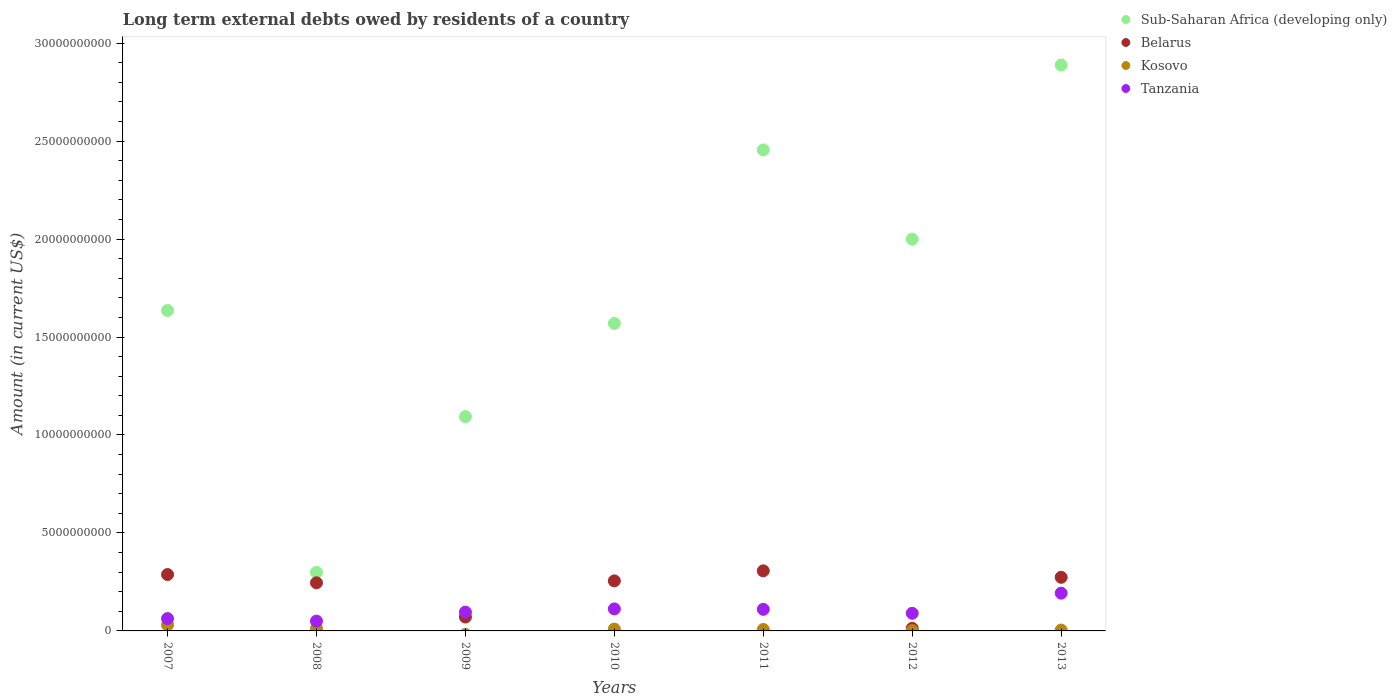Is the number of dotlines equal to the number of legend labels?
Keep it short and to the point. No. What is the amount of long-term external debts owed by residents in Tanzania in 2008?
Make the answer very short. 5.01e+08. Across all years, what is the maximum amount of long-term external debts owed by residents in Kosovo?
Your answer should be very brief. 3.07e+08. Across all years, what is the minimum amount of long-term external debts owed by residents in Tanzania?
Your response must be concise. 5.01e+08. What is the total amount of long-term external debts owed by residents in Belarus in the graph?
Make the answer very short. 1.45e+1. What is the difference between the amount of long-term external debts owed by residents in Sub-Saharan Africa (developing only) in 2010 and that in 2013?
Provide a short and direct response. -1.32e+1. What is the difference between the amount of long-term external debts owed by residents in Belarus in 2009 and the amount of long-term external debts owed by residents in Sub-Saharan Africa (developing only) in 2007?
Provide a short and direct response. -1.56e+1. What is the average amount of long-term external debts owed by residents in Tanzania per year?
Make the answer very short. 1.02e+09. In the year 2013, what is the difference between the amount of long-term external debts owed by residents in Belarus and amount of long-term external debts owed by residents in Kosovo?
Ensure brevity in your answer.  2.69e+09. What is the ratio of the amount of long-term external debts owed by residents in Tanzania in 2008 to that in 2011?
Your answer should be compact. 0.45. What is the difference between the highest and the second highest amount of long-term external debts owed by residents in Sub-Saharan Africa (developing only)?
Your response must be concise. 4.33e+09. What is the difference between the highest and the lowest amount of long-term external debts owed by residents in Sub-Saharan Africa (developing only)?
Offer a terse response. 2.59e+1. In how many years, is the amount of long-term external debts owed by residents in Belarus greater than the average amount of long-term external debts owed by residents in Belarus taken over all years?
Ensure brevity in your answer.  5. Is the sum of the amount of long-term external debts owed by residents in Belarus in 2007 and 2011 greater than the maximum amount of long-term external debts owed by residents in Sub-Saharan Africa (developing only) across all years?
Offer a terse response. No. Is it the case that in every year, the sum of the amount of long-term external debts owed by residents in Tanzania and amount of long-term external debts owed by residents in Sub-Saharan Africa (developing only)  is greater than the sum of amount of long-term external debts owed by residents in Belarus and amount of long-term external debts owed by residents in Kosovo?
Offer a terse response. Yes. Is it the case that in every year, the sum of the amount of long-term external debts owed by residents in Kosovo and amount of long-term external debts owed by residents in Sub-Saharan Africa (developing only)  is greater than the amount of long-term external debts owed by residents in Tanzania?
Ensure brevity in your answer.  Yes. Does the amount of long-term external debts owed by residents in Sub-Saharan Africa (developing only) monotonically increase over the years?
Keep it short and to the point. No. Is the amount of long-term external debts owed by residents in Sub-Saharan Africa (developing only) strictly greater than the amount of long-term external debts owed by residents in Belarus over the years?
Your answer should be compact. Yes. How many years are there in the graph?
Give a very brief answer. 7. Are the values on the major ticks of Y-axis written in scientific E-notation?
Your response must be concise. No. Does the graph contain grids?
Make the answer very short. No. How many legend labels are there?
Your response must be concise. 4. What is the title of the graph?
Make the answer very short. Long term external debts owed by residents of a country. Does "Slovenia" appear as one of the legend labels in the graph?
Offer a very short reply. No. What is the label or title of the X-axis?
Offer a terse response. Years. What is the Amount (in current US$) in Sub-Saharan Africa (developing only) in 2007?
Offer a terse response. 1.64e+1. What is the Amount (in current US$) in Belarus in 2007?
Your response must be concise. 2.88e+09. What is the Amount (in current US$) in Kosovo in 2007?
Provide a succinct answer. 3.07e+08. What is the Amount (in current US$) of Tanzania in 2007?
Provide a short and direct response. 6.30e+08. What is the Amount (in current US$) of Sub-Saharan Africa (developing only) in 2008?
Make the answer very short. 2.99e+09. What is the Amount (in current US$) in Belarus in 2008?
Provide a succinct answer. 2.46e+09. What is the Amount (in current US$) in Kosovo in 2008?
Offer a very short reply. 1.24e+08. What is the Amount (in current US$) in Tanzania in 2008?
Ensure brevity in your answer.  5.01e+08. What is the Amount (in current US$) of Sub-Saharan Africa (developing only) in 2009?
Offer a terse response. 1.09e+1. What is the Amount (in current US$) of Belarus in 2009?
Give a very brief answer. 7.09e+08. What is the Amount (in current US$) of Tanzania in 2009?
Provide a short and direct response. 9.60e+08. What is the Amount (in current US$) in Sub-Saharan Africa (developing only) in 2010?
Your answer should be compact. 1.57e+1. What is the Amount (in current US$) in Belarus in 2010?
Your answer should be compact. 2.55e+09. What is the Amount (in current US$) of Kosovo in 2010?
Your response must be concise. 9.39e+07. What is the Amount (in current US$) in Tanzania in 2010?
Your answer should be very brief. 1.12e+09. What is the Amount (in current US$) of Sub-Saharan Africa (developing only) in 2011?
Provide a succinct answer. 2.45e+1. What is the Amount (in current US$) in Belarus in 2011?
Ensure brevity in your answer.  3.07e+09. What is the Amount (in current US$) in Kosovo in 2011?
Your answer should be very brief. 7.35e+07. What is the Amount (in current US$) of Tanzania in 2011?
Offer a very short reply. 1.10e+09. What is the Amount (in current US$) of Sub-Saharan Africa (developing only) in 2012?
Offer a terse response. 2.00e+1. What is the Amount (in current US$) in Belarus in 2012?
Your answer should be compact. 1.30e+08. What is the Amount (in current US$) of Kosovo in 2012?
Provide a succinct answer. 1.53e+07. What is the Amount (in current US$) in Tanzania in 2012?
Give a very brief answer. 9.00e+08. What is the Amount (in current US$) in Sub-Saharan Africa (developing only) in 2013?
Provide a short and direct response. 2.89e+1. What is the Amount (in current US$) in Belarus in 2013?
Ensure brevity in your answer.  2.74e+09. What is the Amount (in current US$) in Kosovo in 2013?
Offer a very short reply. 4.40e+07. What is the Amount (in current US$) of Tanzania in 2013?
Provide a short and direct response. 1.93e+09. Across all years, what is the maximum Amount (in current US$) in Sub-Saharan Africa (developing only)?
Keep it short and to the point. 2.89e+1. Across all years, what is the maximum Amount (in current US$) in Belarus?
Keep it short and to the point. 3.07e+09. Across all years, what is the maximum Amount (in current US$) of Kosovo?
Offer a very short reply. 3.07e+08. Across all years, what is the maximum Amount (in current US$) of Tanzania?
Ensure brevity in your answer.  1.93e+09. Across all years, what is the minimum Amount (in current US$) of Sub-Saharan Africa (developing only)?
Give a very brief answer. 2.99e+09. Across all years, what is the minimum Amount (in current US$) in Belarus?
Offer a terse response. 1.30e+08. Across all years, what is the minimum Amount (in current US$) of Tanzania?
Give a very brief answer. 5.01e+08. What is the total Amount (in current US$) of Sub-Saharan Africa (developing only) in the graph?
Offer a terse response. 1.19e+11. What is the total Amount (in current US$) of Belarus in the graph?
Your answer should be compact. 1.45e+1. What is the total Amount (in current US$) in Kosovo in the graph?
Your answer should be compact. 6.57e+08. What is the total Amount (in current US$) of Tanzania in the graph?
Offer a very short reply. 7.14e+09. What is the difference between the Amount (in current US$) of Sub-Saharan Africa (developing only) in 2007 and that in 2008?
Provide a succinct answer. 1.34e+1. What is the difference between the Amount (in current US$) in Belarus in 2007 and that in 2008?
Provide a succinct answer. 4.21e+08. What is the difference between the Amount (in current US$) of Kosovo in 2007 and that in 2008?
Your answer should be very brief. 1.83e+08. What is the difference between the Amount (in current US$) in Tanzania in 2007 and that in 2008?
Give a very brief answer. 1.29e+08. What is the difference between the Amount (in current US$) in Sub-Saharan Africa (developing only) in 2007 and that in 2009?
Offer a terse response. 5.42e+09. What is the difference between the Amount (in current US$) of Belarus in 2007 and that in 2009?
Provide a short and direct response. 2.17e+09. What is the difference between the Amount (in current US$) in Tanzania in 2007 and that in 2009?
Offer a terse response. -3.30e+08. What is the difference between the Amount (in current US$) of Sub-Saharan Africa (developing only) in 2007 and that in 2010?
Keep it short and to the point. 6.61e+08. What is the difference between the Amount (in current US$) of Belarus in 2007 and that in 2010?
Your answer should be compact. 3.24e+08. What is the difference between the Amount (in current US$) in Kosovo in 2007 and that in 2010?
Ensure brevity in your answer.  2.13e+08. What is the difference between the Amount (in current US$) of Tanzania in 2007 and that in 2010?
Provide a short and direct response. -4.93e+08. What is the difference between the Amount (in current US$) in Sub-Saharan Africa (developing only) in 2007 and that in 2011?
Give a very brief answer. -8.20e+09. What is the difference between the Amount (in current US$) in Belarus in 2007 and that in 2011?
Ensure brevity in your answer.  -1.90e+08. What is the difference between the Amount (in current US$) in Kosovo in 2007 and that in 2011?
Your answer should be very brief. 2.33e+08. What is the difference between the Amount (in current US$) of Tanzania in 2007 and that in 2011?
Keep it short and to the point. -4.73e+08. What is the difference between the Amount (in current US$) of Sub-Saharan Africa (developing only) in 2007 and that in 2012?
Keep it short and to the point. -3.64e+09. What is the difference between the Amount (in current US$) in Belarus in 2007 and that in 2012?
Your answer should be compact. 2.75e+09. What is the difference between the Amount (in current US$) in Kosovo in 2007 and that in 2012?
Keep it short and to the point. 2.91e+08. What is the difference between the Amount (in current US$) of Tanzania in 2007 and that in 2012?
Your answer should be very brief. -2.70e+08. What is the difference between the Amount (in current US$) in Sub-Saharan Africa (developing only) in 2007 and that in 2013?
Keep it short and to the point. -1.25e+1. What is the difference between the Amount (in current US$) of Belarus in 2007 and that in 2013?
Offer a very short reply. 1.40e+08. What is the difference between the Amount (in current US$) in Kosovo in 2007 and that in 2013?
Keep it short and to the point. 2.63e+08. What is the difference between the Amount (in current US$) of Tanzania in 2007 and that in 2013?
Keep it short and to the point. -1.30e+09. What is the difference between the Amount (in current US$) in Sub-Saharan Africa (developing only) in 2008 and that in 2009?
Provide a succinct answer. -7.95e+09. What is the difference between the Amount (in current US$) of Belarus in 2008 and that in 2009?
Provide a succinct answer. 1.75e+09. What is the difference between the Amount (in current US$) in Tanzania in 2008 and that in 2009?
Offer a very short reply. -4.59e+08. What is the difference between the Amount (in current US$) of Sub-Saharan Africa (developing only) in 2008 and that in 2010?
Provide a succinct answer. -1.27e+1. What is the difference between the Amount (in current US$) in Belarus in 2008 and that in 2010?
Your answer should be very brief. -9.73e+07. What is the difference between the Amount (in current US$) in Kosovo in 2008 and that in 2010?
Ensure brevity in your answer.  2.99e+07. What is the difference between the Amount (in current US$) of Tanzania in 2008 and that in 2010?
Provide a short and direct response. -6.22e+08. What is the difference between the Amount (in current US$) of Sub-Saharan Africa (developing only) in 2008 and that in 2011?
Give a very brief answer. -2.16e+1. What is the difference between the Amount (in current US$) of Belarus in 2008 and that in 2011?
Your response must be concise. -6.11e+08. What is the difference between the Amount (in current US$) in Kosovo in 2008 and that in 2011?
Your answer should be compact. 5.03e+07. What is the difference between the Amount (in current US$) of Tanzania in 2008 and that in 2011?
Your answer should be compact. -6.02e+08. What is the difference between the Amount (in current US$) of Sub-Saharan Africa (developing only) in 2008 and that in 2012?
Keep it short and to the point. -1.70e+1. What is the difference between the Amount (in current US$) in Belarus in 2008 and that in 2012?
Offer a very short reply. 2.33e+09. What is the difference between the Amount (in current US$) of Kosovo in 2008 and that in 2012?
Your answer should be very brief. 1.08e+08. What is the difference between the Amount (in current US$) of Tanzania in 2008 and that in 2012?
Provide a short and direct response. -3.99e+08. What is the difference between the Amount (in current US$) in Sub-Saharan Africa (developing only) in 2008 and that in 2013?
Make the answer very short. -2.59e+1. What is the difference between the Amount (in current US$) of Belarus in 2008 and that in 2013?
Ensure brevity in your answer.  -2.81e+08. What is the difference between the Amount (in current US$) of Kosovo in 2008 and that in 2013?
Your answer should be compact. 7.98e+07. What is the difference between the Amount (in current US$) of Tanzania in 2008 and that in 2013?
Your response must be concise. -1.43e+09. What is the difference between the Amount (in current US$) in Sub-Saharan Africa (developing only) in 2009 and that in 2010?
Offer a very short reply. -4.76e+09. What is the difference between the Amount (in current US$) in Belarus in 2009 and that in 2010?
Offer a very short reply. -1.84e+09. What is the difference between the Amount (in current US$) of Tanzania in 2009 and that in 2010?
Keep it short and to the point. -1.63e+08. What is the difference between the Amount (in current US$) of Sub-Saharan Africa (developing only) in 2009 and that in 2011?
Your response must be concise. -1.36e+1. What is the difference between the Amount (in current US$) in Belarus in 2009 and that in 2011?
Give a very brief answer. -2.36e+09. What is the difference between the Amount (in current US$) of Tanzania in 2009 and that in 2011?
Provide a succinct answer. -1.43e+08. What is the difference between the Amount (in current US$) of Sub-Saharan Africa (developing only) in 2009 and that in 2012?
Keep it short and to the point. -9.06e+09. What is the difference between the Amount (in current US$) in Belarus in 2009 and that in 2012?
Offer a terse response. 5.79e+08. What is the difference between the Amount (in current US$) in Tanzania in 2009 and that in 2012?
Make the answer very short. 6.00e+07. What is the difference between the Amount (in current US$) in Sub-Saharan Africa (developing only) in 2009 and that in 2013?
Give a very brief answer. -1.79e+1. What is the difference between the Amount (in current US$) of Belarus in 2009 and that in 2013?
Provide a short and direct response. -2.03e+09. What is the difference between the Amount (in current US$) of Tanzania in 2009 and that in 2013?
Provide a succinct answer. -9.67e+08. What is the difference between the Amount (in current US$) of Sub-Saharan Africa (developing only) in 2010 and that in 2011?
Your answer should be very brief. -8.86e+09. What is the difference between the Amount (in current US$) of Belarus in 2010 and that in 2011?
Make the answer very short. -5.14e+08. What is the difference between the Amount (in current US$) of Kosovo in 2010 and that in 2011?
Make the answer very short. 2.04e+07. What is the difference between the Amount (in current US$) of Tanzania in 2010 and that in 2011?
Provide a short and direct response. 2.01e+07. What is the difference between the Amount (in current US$) of Sub-Saharan Africa (developing only) in 2010 and that in 2012?
Provide a short and direct response. -4.30e+09. What is the difference between the Amount (in current US$) of Belarus in 2010 and that in 2012?
Make the answer very short. 2.42e+09. What is the difference between the Amount (in current US$) in Kosovo in 2010 and that in 2012?
Offer a terse response. 7.86e+07. What is the difference between the Amount (in current US$) in Tanzania in 2010 and that in 2012?
Make the answer very short. 2.23e+08. What is the difference between the Amount (in current US$) in Sub-Saharan Africa (developing only) in 2010 and that in 2013?
Provide a short and direct response. -1.32e+1. What is the difference between the Amount (in current US$) of Belarus in 2010 and that in 2013?
Provide a short and direct response. -1.83e+08. What is the difference between the Amount (in current US$) in Kosovo in 2010 and that in 2013?
Keep it short and to the point. 5.00e+07. What is the difference between the Amount (in current US$) in Tanzania in 2010 and that in 2013?
Ensure brevity in your answer.  -8.04e+08. What is the difference between the Amount (in current US$) of Sub-Saharan Africa (developing only) in 2011 and that in 2012?
Make the answer very short. 4.55e+09. What is the difference between the Amount (in current US$) in Belarus in 2011 and that in 2012?
Provide a succinct answer. 2.94e+09. What is the difference between the Amount (in current US$) of Kosovo in 2011 and that in 2012?
Offer a very short reply. 5.82e+07. What is the difference between the Amount (in current US$) in Tanzania in 2011 and that in 2012?
Provide a succinct answer. 2.03e+08. What is the difference between the Amount (in current US$) in Sub-Saharan Africa (developing only) in 2011 and that in 2013?
Offer a terse response. -4.33e+09. What is the difference between the Amount (in current US$) in Belarus in 2011 and that in 2013?
Give a very brief answer. 3.30e+08. What is the difference between the Amount (in current US$) in Kosovo in 2011 and that in 2013?
Ensure brevity in your answer.  2.95e+07. What is the difference between the Amount (in current US$) of Tanzania in 2011 and that in 2013?
Offer a terse response. -8.24e+08. What is the difference between the Amount (in current US$) of Sub-Saharan Africa (developing only) in 2012 and that in 2013?
Keep it short and to the point. -8.89e+09. What is the difference between the Amount (in current US$) in Belarus in 2012 and that in 2013?
Make the answer very short. -2.61e+09. What is the difference between the Amount (in current US$) in Kosovo in 2012 and that in 2013?
Your answer should be compact. -2.87e+07. What is the difference between the Amount (in current US$) in Tanzania in 2012 and that in 2013?
Your response must be concise. -1.03e+09. What is the difference between the Amount (in current US$) in Sub-Saharan Africa (developing only) in 2007 and the Amount (in current US$) in Belarus in 2008?
Provide a succinct answer. 1.39e+1. What is the difference between the Amount (in current US$) in Sub-Saharan Africa (developing only) in 2007 and the Amount (in current US$) in Kosovo in 2008?
Your answer should be very brief. 1.62e+1. What is the difference between the Amount (in current US$) in Sub-Saharan Africa (developing only) in 2007 and the Amount (in current US$) in Tanzania in 2008?
Offer a very short reply. 1.59e+1. What is the difference between the Amount (in current US$) of Belarus in 2007 and the Amount (in current US$) of Kosovo in 2008?
Offer a terse response. 2.75e+09. What is the difference between the Amount (in current US$) of Belarus in 2007 and the Amount (in current US$) of Tanzania in 2008?
Provide a succinct answer. 2.38e+09. What is the difference between the Amount (in current US$) in Kosovo in 2007 and the Amount (in current US$) in Tanzania in 2008?
Give a very brief answer. -1.94e+08. What is the difference between the Amount (in current US$) of Sub-Saharan Africa (developing only) in 2007 and the Amount (in current US$) of Belarus in 2009?
Your response must be concise. 1.56e+1. What is the difference between the Amount (in current US$) in Sub-Saharan Africa (developing only) in 2007 and the Amount (in current US$) in Tanzania in 2009?
Your answer should be very brief. 1.54e+1. What is the difference between the Amount (in current US$) of Belarus in 2007 and the Amount (in current US$) of Tanzania in 2009?
Provide a short and direct response. 1.92e+09. What is the difference between the Amount (in current US$) in Kosovo in 2007 and the Amount (in current US$) in Tanzania in 2009?
Your answer should be compact. -6.53e+08. What is the difference between the Amount (in current US$) of Sub-Saharan Africa (developing only) in 2007 and the Amount (in current US$) of Belarus in 2010?
Provide a succinct answer. 1.38e+1. What is the difference between the Amount (in current US$) in Sub-Saharan Africa (developing only) in 2007 and the Amount (in current US$) in Kosovo in 2010?
Offer a terse response. 1.63e+1. What is the difference between the Amount (in current US$) of Sub-Saharan Africa (developing only) in 2007 and the Amount (in current US$) of Tanzania in 2010?
Ensure brevity in your answer.  1.52e+1. What is the difference between the Amount (in current US$) in Belarus in 2007 and the Amount (in current US$) in Kosovo in 2010?
Make the answer very short. 2.78e+09. What is the difference between the Amount (in current US$) of Belarus in 2007 and the Amount (in current US$) of Tanzania in 2010?
Provide a succinct answer. 1.75e+09. What is the difference between the Amount (in current US$) of Kosovo in 2007 and the Amount (in current US$) of Tanzania in 2010?
Give a very brief answer. -8.16e+08. What is the difference between the Amount (in current US$) in Sub-Saharan Africa (developing only) in 2007 and the Amount (in current US$) in Belarus in 2011?
Your response must be concise. 1.33e+1. What is the difference between the Amount (in current US$) in Sub-Saharan Africa (developing only) in 2007 and the Amount (in current US$) in Kosovo in 2011?
Ensure brevity in your answer.  1.63e+1. What is the difference between the Amount (in current US$) in Sub-Saharan Africa (developing only) in 2007 and the Amount (in current US$) in Tanzania in 2011?
Your answer should be compact. 1.52e+1. What is the difference between the Amount (in current US$) in Belarus in 2007 and the Amount (in current US$) in Kosovo in 2011?
Your answer should be very brief. 2.80e+09. What is the difference between the Amount (in current US$) of Belarus in 2007 and the Amount (in current US$) of Tanzania in 2011?
Keep it short and to the point. 1.77e+09. What is the difference between the Amount (in current US$) of Kosovo in 2007 and the Amount (in current US$) of Tanzania in 2011?
Give a very brief answer. -7.96e+08. What is the difference between the Amount (in current US$) in Sub-Saharan Africa (developing only) in 2007 and the Amount (in current US$) in Belarus in 2012?
Provide a succinct answer. 1.62e+1. What is the difference between the Amount (in current US$) in Sub-Saharan Africa (developing only) in 2007 and the Amount (in current US$) in Kosovo in 2012?
Make the answer very short. 1.63e+1. What is the difference between the Amount (in current US$) of Sub-Saharan Africa (developing only) in 2007 and the Amount (in current US$) of Tanzania in 2012?
Your response must be concise. 1.55e+1. What is the difference between the Amount (in current US$) of Belarus in 2007 and the Amount (in current US$) of Kosovo in 2012?
Provide a succinct answer. 2.86e+09. What is the difference between the Amount (in current US$) of Belarus in 2007 and the Amount (in current US$) of Tanzania in 2012?
Offer a terse response. 1.98e+09. What is the difference between the Amount (in current US$) in Kosovo in 2007 and the Amount (in current US$) in Tanzania in 2012?
Keep it short and to the point. -5.93e+08. What is the difference between the Amount (in current US$) in Sub-Saharan Africa (developing only) in 2007 and the Amount (in current US$) in Belarus in 2013?
Provide a succinct answer. 1.36e+1. What is the difference between the Amount (in current US$) in Sub-Saharan Africa (developing only) in 2007 and the Amount (in current US$) in Kosovo in 2013?
Your answer should be compact. 1.63e+1. What is the difference between the Amount (in current US$) in Sub-Saharan Africa (developing only) in 2007 and the Amount (in current US$) in Tanzania in 2013?
Ensure brevity in your answer.  1.44e+1. What is the difference between the Amount (in current US$) of Belarus in 2007 and the Amount (in current US$) of Kosovo in 2013?
Your answer should be very brief. 2.83e+09. What is the difference between the Amount (in current US$) in Belarus in 2007 and the Amount (in current US$) in Tanzania in 2013?
Provide a succinct answer. 9.50e+08. What is the difference between the Amount (in current US$) of Kosovo in 2007 and the Amount (in current US$) of Tanzania in 2013?
Provide a short and direct response. -1.62e+09. What is the difference between the Amount (in current US$) in Sub-Saharan Africa (developing only) in 2008 and the Amount (in current US$) in Belarus in 2009?
Offer a very short reply. 2.28e+09. What is the difference between the Amount (in current US$) in Sub-Saharan Africa (developing only) in 2008 and the Amount (in current US$) in Tanzania in 2009?
Offer a very short reply. 2.03e+09. What is the difference between the Amount (in current US$) in Belarus in 2008 and the Amount (in current US$) in Tanzania in 2009?
Ensure brevity in your answer.  1.50e+09. What is the difference between the Amount (in current US$) in Kosovo in 2008 and the Amount (in current US$) in Tanzania in 2009?
Ensure brevity in your answer.  -8.36e+08. What is the difference between the Amount (in current US$) in Sub-Saharan Africa (developing only) in 2008 and the Amount (in current US$) in Belarus in 2010?
Offer a very short reply. 4.35e+08. What is the difference between the Amount (in current US$) in Sub-Saharan Africa (developing only) in 2008 and the Amount (in current US$) in Kosovo in 2010?
Make the answer very short. 2.89e+09. What is the difference between the Amount (in current US$) in Sub-Saharan Africa (developing only) in 2008 and the Amount (in current US$) in Tanzania in 2010?
Your answer should be very brief. 1.87e+09. What is the difference between the Amount (in current US$) in Belarus in 2008 and the Amount (in current US$) in Kosovo in 2010?
Ensure brevity in your answer.  2.36e+09. What is the difference between the Amount (in current US$) in Belarus in 2008 and the Amount (in current US$) in Tanzania in 2010?
Provide a short and direct response. 1.33e+09. What is the difference between the Amount (in current US$) in Kosovo in 2008 and the Amount (in current US$) in Tanzania in 2010?
Offer a very short reply. -9.99e+08. What is the difference between the Amount (in current US$) in Sub-Saharan Africa (developing only) in 2008 and the Amount (in current US$) in Belarus in 2011?
Give a very brief answer. -7.81e+07. What is the difference between the Amount (in current US$) of Sub-Saharan Africa (developing only) in 2008 and the Amount (in current US$) of Kosovo in 2011?
Offer a very short reply. 2.92e+09. What is the difference between the Amount (in current US$) of Sub-Saharan Africa (developing only) in 2008 and the Amount (in current US$) of Tanzania in 2011?
Your answer should be compact. 1.89e+09. What is the difference between the Amount (in current US$) in Belarus in 2008 and the Amount (in current US$) in Kosovo in 2011?
Your response must be concise. 2.38e+09. What is the difference between the Amount (in current US$) in Belarus in 2008 and the Amount (in current US$) in Tanzania in 2011?
Your answer should be very brief. 1.35e+09. What is the difference between the Amount (in current US$) in Kosovo in 2008 and the Amount (in current US$) in Tanzania in 2011?
Your response must be concise. -9.79e+08. What is the difference between the Amount (in current US$) of Sub-Saharan Africa (developing only) in 2008 and the Amount (in current US$) of Belarus in 2012?
Your response must be concise. 2.86e+09. What is the difference between the Amount (in current US$) of Sub-Saharan Africa (developing only) in 2008 and the Amount (in current US$) of Kosovo in 2012?
Ensure brevity in your answer.  2.97e+09. What is the difference between the Amount (in current US$) of Sub-Saharan Africa (developing only) in 2008 and the Amount (in current US$) of Tanzania in 2012?
Provide a short and direct response. 2.09e+09. What is the difference between the Amount (in current US$) in Belarus in 2008 and the Amount (in current US$) in Kosovo in 2012?
Ensure brevity in your answer.  2.44e+09. What is the difference between the Amount (in current US$) in Belarus in 2008 and the Amount (in current US$) in Tanzania in 2012?
Your answer should be compact. 1.56e+09. What is the difference between the Amount (in current US$) of Kosovo in 2008 and the Amount (in current US$) of Tanzania in 2012?
Make the answer very short. -7.76e+08. What is the difference between the Amount (in current US$) in Sub-Saharan Africa (developing only) in 2008 and the Amount (in current US$) in Belarus in 2013?
Make the answer very short. 2.52e+08. What is the difference between the Amount (in current US$) in Sub-Saharan Africa (developing only) in 2008 and the Amount (in current US$) in Kosovo in 2013?
Give a very brief answer. 2.94e+09. What is the difference between the Amount (in current US$) in Sub-Saharan Africa (developing only) in 2008 and the Amount (in current US$) in Tanzania in 2013?
Make the answer very short. 1.06e+09. What is the difference between the Amount (in current US$) of Belarus in 2008 and the Amount (in current US$) of Kosovo in 2013?
Your answer should be very brief. 2.41e+09. What is the difference between the Amount (in current US$) of Belarus in 2008 and the Amount (in current US$) of Tanzania in 2013?
Your answer should be very brief. 5.29e+08. What is the difference between the Amount (in current US$) of Kosovo in 2008 and the Amount (in current US$) of Tanzania in 2013?
Give a very brief answer. -1.80e+09. What is the difference between the Amount (in current US$) in Sub-Saharan Africa (developing only) in 2009 and the Amount (in current US$) in Belarus in 2010?
Ensure brevity in your answer.  8.38e+09. What is the difference between the Amount (in current US$) of Sub-Saharan Africa (developing only) in 2009 and the Amount (in current US$) of Kosovo in 2010?
Offer a terse response. 1.08e+1. What is the difference between the Amount (in current US$) in Sub-Saharan Africa (developing only) in 2009 and the Amount (in current US$) in Tanzania in 2010?
Your answer should be compact. 9.81e+09. What is the difference between the Amount (in current US$) in Belarus in 2009 and the Amount (in current US$) in Kosovo in 2010?
Your answer should be compact. 6.15e+08. What is the difference between the Amount (in current US$) of Belarus in 2009 and the Amount (in current US$) of Tanzania in 2010?
Your answer should be compact. -4.14e+08. What is the difference between the Amount (in current US$) in Sub-Saharan Africa (developing only) in 2009 and the Amount (in current US$) in Belarus in 2011?
Offer a very short reply. 7.87e+09. What is the difference between the Amount (in current US$) of Sub-Saharan Africa (developing only) in 2009 and the Amount (in current US$) of Kosovo in 2011?
Your answer should be compact. 1.09e+1. What is the difference between the Amount (in current US$) in Sub-Saharan Africa (developing only) in 2009 and the Amount (in current US$) in Tanzania in 2011?
Keep it short and to the point. 9.83e+09. What is the difference between the Amount (in current US$) of Belarus in 2009 and the Amount (in current US$) of Kosovo in 2011?
Provide a succinct answer. 6.36e+08. What is the difference between the Amount (in current US$) of Belarus in 2009 and the Amount (in current US$) of Tanzania in 2011?
Provide a short and direct response. -3.94e+08. What is the difference between the Amount (in current US$) of Sub-Saharan Africa (developing only) in 2009 and the Amount (in current US$) of Belarus in 2012?
Provide a short and direct response. 1.08e+1. What is the difference between the Amount (in current US$) in Sub-Saharan Africa (developing only) in 2009 and the Amount (in current US$) in Kosovo in 2012?
Your response must be concise. 1.09e+1. What is the difference between the Amount (in current US$) of Sub-Saharan Africa (developing only) in 2009 and the Amount (in current US$) of Tanzania in 2012?
Offer a terse response. 1.00e+1. What is the difference between the Amount (in current US$) in Belarus in 2009 and the Amount (in current US$) in Kosovo in 2012?
Your answer should be very brief. 6.94e+08. What is the difference between the Amount (in current US$) in Belarus in 2009 and the Amount (in current US$) in Tanzania in 2012?
Provide a short and direct response. -1.90e+08. What is the difference between the Amount (in current US$) of Sub-Saharan Africa (developing only) in 2009 and the Amount (in current US$) of Belarus in 2013?
Ensure brevity in your answer.  8.20e+09. What is the difference between the Amount (in current US$) in Sub-Saharan Africa (developing only) in 2009 and the Amount (in current US$) in Kosovo in 2013?
Your response must be concise. 1.09e+1. What is the difference between the Amount (in current US$) in Sub-Saharan Africa (developing only) in 2009 and the Amount (in current US$) in Tanzania in 2013?
Make the answer very short. 9.01e+09. What is the difference between the Amount (in current US$) of Belarus in 2009 and the Amount (in current US$) of Kosovo in 2013?
Keep it short and to the point. 6.65e+08. What is the difference between the Amount (in current US$) in Belarus in 2009 and the Amount (in current US$) in Tanzania in 2013?
Keep it short and to the point. -1.22e+09. What is the difference between the Amount (in current US$) in Sub-Saharan Africa (developing only) in 2010 and the Amount (in current US$) in Belarus in 2011?
Provide a succinct answer. 1.26e+1. What is the difference between the Amount (in current US$) of Sub-Saharan Africa (developing only) in 2010 and the Amount (in current US$) of Kosovo in 2011?
Give a very brief answer. 1.56e+1. What is the difference between the Amount (in current US$) of Sub-Saharan Africa (developing only) in 2010 and the Amount (in current US$) of Tanzania in 2011?
Offer a very short reply. 1.46e+1. What is the difference between the Amount (in current US$) of Belarus in 2010 and the Amount (in current US$) of Kosovo in 2011?
Ensure brevity in your answer.  2.48e+09. What is the difference between the Amount (in current US$) in Belarus in 2010 and the Amount (in current US$) in Tanzania in 2011?
Your response must be concise. 1.45e+09. What is the difference between the Amount (in current US$) of Kosovo in 2010 and the Amount (in current US$) of Tanzania in 2011?
Provide a short and direct response. -1.01e+09. What is the difference between the Amount (in current US$) in Sub-Saharan Africa (developing only) in 2010 and the Amount (in current US$) in Belarus in 2012?
Your answer should be very brief. 1.56e+1. What is the difference between the Amount (in current US$) in Sub-Saharan Africa (developing only) in 2010 and the Amount (in current US$) in Kosovo in 2012?
Your answer should be compact. 1.57e+1. What is the difference between the Amount (in current US$) of Sub-Saharan Africa (developing only) in 2010 and the Amount (in current US$) of Tanzania in 2012?
Offer a terse response. 1.48e+1. What is the difference between the Amount (in current US$) in Belarus in 2010 and the Amount (in current US$) in Kosovo in 2012?
Make the answer very short. 2.54e+09. What is the difference between the Amount (in current US$) in Belarus in 2010 and the Amount (in current US$) in Tanzania in 2012?
Your answer should be very brief. 1.65e+09. What is the difference between the Amount (in current US$) in Kosovo in 2010 and the Amount (in current US$) in Tanzania in 2012?
Provide a succinct answer. -8.06e+08. What is the difference between the Amount (in current US$) of Sub-Saharan Africa (developing only) in 2010 and the Amount (in current US$) of Belarus in 2013?
Make the answer very short. 1.30e+1. What is the difference between the Amount (in current US$) of Sub-Saharan Africa (developing only) in 2010 and the Amount (in current US$) of Kosovo in 2013?
Offer a terse response. 1.56e+1. What is the difference between the Amount (in current US$) of Sub-Saharan Africa (developing only) in 2010 and the Amount (in current US$) of Tanzania in 2013?
Provide a short and direct response. 1.38e+1. What is the difference between the Amount (in current US$) of Belarus in 2010 and the Amount (in current US$) of Kosovo in 2013?
Make the answer very short. 2.51e+09. What is the difference between the Amount (in current US$) of Belarus in 2010 and the Amount (in current US$) of Tanzania in 2013?
Provide a short and direct response. 6.26e+08. What is the difference between the Amount (in current US$) in Kosovo in 2010 and the Amount (in current US$) in Tanzania in 2013?
Provide a short and direct response. -1.83e+09. What is the difference between the Amount (in current US$) of Sub-Saharan Africa (developing only) in 2011 and the Amount (in current US$) of Belarus in 2012?
Give a very brief answer. 2.44e+1. What is the difference between the Amount (in current US$) in Sub-Saharan Africa (developing only) in 2011 and the Amount (in current US$) in Kosovo in 2012?
Make the answer very short. 2.45e+1. What is the difference between the Amount (in current US$) in Sub-Saharan Africa (developing only) in 2011 and the Amount (in current US$) in Tanzania in 2012?
Offer a very short reply. 2.36e+1. What is the difference between the Amount (in current US$) in Belarus in 2011 and the Amount (in current US$) in Kosovo in 2012?
Offer a terse response. 3.05e+09. What is the difference between the Amount (in current US$) in Belarus in 2011 and the Amount (in current US$) in Tanzania in 2012?
Your response must be concise. 2.17e+09. What is the difference between the Amount (in current US$) in Kosovo in 2011 and the Amount (in current US$) in Tanzania in 2012?
Ensure brevity in your answer.  -8.26e+08. What is the difference between the Amount (in current US$) of Sub-Saharan Africa (developing only) in 2011 and the Amount (in current US$) of Belarus in 2013?
Keep it short and to the point. 2.18e+1. What is the difference between the Amount (in current US$) of Sub-Saharan Africa (developing only) in 2011 and the Amount (in current US$) of Kosovo in 2013?
Keep it short and to the point. 2.45e+1. What is the difference between the Amount (in current US$) of Sub-Saharan Africa (developing only) in 2011 and the Amount (in current US$) of Tanzania in 2013?
Your response must be concise. 2.26e+1. What is the difference between the Amount (in current US$) in Belarus in 2011 and the Amount (in current US$) in Kosovo in 2013?
Make the answer very short. 3.02e+09. What is the difference between the Amount (in current US$) in Belarus in 2011 and the Amount (in current US$) in Tanzania in 2013?
Your answer should be compact. 1.14e+09. What is the difference between the Amount (in current US$) of Kosovo in 2011 and the Amount (in current US$) of Tanzania in 2013?
Offer a terse response. -1.85e+09. What is the difference between the Amount (in current US$) of Sub-Saharan Africa (developing only) in 2012 and the Amount (in current US$) of Belarus in 2013?
Your answer should be compact. 1.73e+1. What is the difference between the Amount (in current US$) in Sub-Saharan Africa (developing only) in 2012 and the Amount (in current US$) in Kosovo in 2013?
Your response must be concise. 2.00e+1. What is the difference between the Amount (in current US$) of Sub-Saharan Africa (developing only) in 2012 and the Amount (in current US$) of Tanzania in 2013?
Keep it short and to the point. 1.81e+1. What is the difference between the Amount (in current US$) in Belarus in 2012 and the Amount (in current US$) in Kosovo in 2013?
Offer a terse response. 8.62e+07. What is the difference between the Amount (in current US$) in Belarus in 2012 and the Amount (in current US$) in Tanzania in 2013?
Keep it short and to the point. -1.80e+09. What is the difference between the Amount (in current US$) of Kosovo in 2012 and the Amount (in current US$) of Tanzania in 2013?
Your answer should be compact. -1.91e+09. What is the average Amount (in current US$) of Sub-Saharan Africa (developing only) per year?
Your answer should be compact. 1.71e+1. What is the average Amount (in current US$) in Belarus per year?
Your answer should be compact. 2.08e+09. What is the average Amount (in current US$) in Kosovo per year?
Ensure brevity in your answer.  9.39e+07. What is the average Amount (in current US$) of Tanzania per year?
Keep it short and to the point. 1.02e+09. In the year 2007, what is the difference between the Amount (in current US$) of Sub-Saharan Africa (developing only) and Amount (in current US$) of Belarus?
Your answer should be compact. 1.35e+1. In the year 2007, what is the difference between the Amount (in current US$) of Sub-Saharan Africa (developing only) and Amount (in current US$) of Kosovo?
Offer a terse response. 1.60e+1. In the year 2007, what is the difference between the Amount (in current US$) of Sub-Saharan Africa (developing only) and Amount (in current US$) of Tanzania?
Give a very brief answer. 1.57e+1. In the year 2007, what is the difference between the Amount (in current US$) in Belarus and Amount (in current US$) in Kosovo?
Your response must be concise. 2.57e+09. In the year 2007, what is the difference between the Amount (in current US$) in Belarus and Amount (in current US$) in Tanzania?
Your response must be concise. 2.25e+09. In the year 2007, what is the difference between the Amount (in current US$) of Kosovo and Amount (in current US$) of Tanzania?
Your answer should be very brief. -3.23e+08. In the year 2008, what is the difference between the Amount (in current US$) in Sub-Saharan Africa (developing only) and Amount (in current US$) in Belarus?
Your answer should be compact. 5.33e+08. In the year 2008, what is the difference between the Amount (in current US$) in Sub-Saharan Africa (developing only) and Amount (in current US$) in Kosovo?
Your response must be concise. 2.86e+09. In the year 2008, what is the difference between the Amount (in current US$) in Sub-Saharan Africa (developing only) and Amount (in current US$) in Tanzania?
Make the answer very short. 2.49e+09. In the year 2008, what is the difference between the Amount (in current US$) of Belarus and Amount (in current US$) of Kosovo?
Your response must be concise. 2.33e+09. In the year 2008, what is the difference between the Amount (in current US$) in Belarus and Amount (in current US$) in Tanzania?
Ensure brevity in your answer.  1.95e+09. In the year 2008, what is the difference between the Amount (in current US$) in Kosovo and Amount (in current US$) in Tanzania?
Offer a very short reply. -3.77e+08. In the year 2009, what is the difference between the Amount (in current US$) in Sub-Saharan Africa (developing only) and Amount (in current US$) in Belarus?
Provide a succinct answer. 1.02e+1. In the year 2009, what is the difference between the Amount (in current US$) of Sub-Saharan Africa (developing only) and Amount (in current US$) of Tanzania?
Provide a succinct answer. 9.98e+09. In the year 2009, what is the difference between the Amount (in current US$) in Belarus and Amount (in current US$) in Tanzania?
Make the answer very short. -2.50e+08. In the year 2010, what is the difference between the Amount (in current US$) of Sub-Saharan Africa (developing only) and Amount (in current US$) of Belarus?
Make the answer very short. 1.31e+1. In the year 2010, what is the difference between the Amount (in current US$) of Sub-Saharan Africa (developing only) and Amount (in current US$) of Kosovo?
Offer a very short reply. 1.56e+1. In the year 2010, what is the difference between the Amount (in current US$) in Sub-Saharan Africa (developing only) and Amount (in current US$) in Tanzania?
Your answer should be compact. 1.46e+1. In the year 2010, what is the difference between the Amount (in current US$) in Belarus and Amount (in current US$) in Kosovo?
Ensure brevity in your answer.  2.46e+09. In the year 2010, what is the difference between the Amount (in current US$) of Belarus and Amount (in current US$) of Tanzania?
Provide a succinct answer. 1.43e+09. In the year 2010, what is the difference between the Amount (in current US$) of Kosovo and Amount (in current US$) of Tanzania?
Keep it short and to the point. -1.03e+09. In the year 2011, what is the difference between the Amount (in current US$) in Sub-Saharan Africa (developing only) and Amount (in current US$) in Belarus?
Give a very brief answer. 2.15e+1. In the year 2011, what is the difference between the Amount (in current US$) of Sub-Saharan Africa (developing only) and Amount (in current US$) of Kosovo?
Offer a terse response. 2.45e+1. In the year 2011, what is the difference between the Amount (in current US$) in Sub-Saharan Africa (developing only) and Amount (in current US$) in Tanzania?
Your response must be concise. 2.34e+1. In the year 2011, what is the difference between the Amount (in current US$) of Belarus and Amount (in current US$) of Kosovo?
Give a very brief answer. 2.99e+09. In the year 2011, what is the difference between the Amount (in current US$) in Belarus and Amount (in current US$) in Tanzania?
Your answer should be very brief. 1.96e+09. In the year 2011, what is the difference between the Amount (in current US$) of Kosovo and Amount (in current US$) of Tanzania?
Offer a terse response. -1.03e+09. In the year 2012, what is the difference between the Amount (in current US$) in Sub-Saharan Africa (developing only) and Amount (in current US$) in Belarus?
Ensure brevity in your answer.  1.99e+1. In the year 2012, what is the difference between the Amount (in current US$) of Sub-Saharan Africa (developing only) and Amount (in current US$) of Kosovo?
Your answer should be very brief. 2.00e+1. In the year 2012, what is the difference between the Amount (in current US$) of Sub-Saharan Africa (developing only) and Amount (in current US$) of Tanzania?
Offer a terse response. 1.91e+1. In the year 2012, what is the difference between the Amount (in current US$) in Belarus and Amount (in current US$) in Kosovo?
Keep it short and to the point. 1.15e+08. In the year 2012, what is the difference between the Amount (in current US$) in Belarus and Amount (in current US$) in Tanzania?
Your answer should be very brief. -7.69e+08. In the year 2012, what is the difference between the Amount (in current US$) of Kosovo and Amount (in current US$) of Tanzania?
Give a very brief answer. -8.84e+08. In the year 2013, what is the difference between the Amount (in current US$) in Sub-Saharan Africa (developing only) and Amount (in current US$) in Belarus?
Make the answer very short. 2.61e+1. In the year 2013, what is the difference between the Amount (in current US$) of Sub-Saharan Africa (developing only) and Amount (in current US$) of Kosovo?
Your answer should be very brief. 2.88e+1. In the year 2013, what is the difference between the Amount (in current US$) in Sub-Saharan Africa (developing only) and Amount (in current US$) in Tanzania?
Keep it short and to the point. 2.70e+1. In the year 2013, what is the difference between the Amount (in current US$) of Belarus and Amount (in current US$) of Kosovo?
Your answer should be very brief. 2.69e+09. In the year 2013, what is the difference between the Amount (in current US$) in Belarus and Amount (in current US$) in Tanzania?
Offer a terse response. 8.10e+08. In the year 2013, what is the difference between the Amount (in current US$) of Kosovo and Amount (in current US$) of Tanzania?
Provide a succinct answer. -1.88e+09. What is the ratio of the Amount (in current US$) in Sub-Saharan Africa (developing only) in 2007 to that in 2008?
Your response must be concise. 5.47. What is the ratio of the Amount (in current US$) in Belarus in 2007 to that in 2008?
Provide a succinct answer. 1.17. What is the ratio of the Amount (in current US$) in Kosovo in 2007 to that in 2008?
Give a very brief answer. 2.48. What is the ratio of the Amount (in current US$) of Tanzania in 2007 to that in 2008?
Your answer should be very brief. 1.26. What is the ratio of the Amount (in current US$) in Sub-Saharan Africa (developing only) in 2007 to that in 2009?
Offer a terse response. 1.5. What is the ratio of the Amount (in current US$) of Belarus in 2007 to that in 2009?
Provide a short and direct response. 4.06. What is the ratio of the Amount (in current US$) of Tanzania in 2007 to that in 2009?
Offer a terse response. 0.66. What is the ratio of the Amount (in current US$) in Sub-Saharan Africa (developing only) in 2007 to that in 2010?
Keep it short and to the point. 1.04. What is the ratio of the Amount (in current US$) of Belarus in 2007 to that in 2010?
Give a very brief answer. 1.13. What is the ratio of the Amount (in current US$) of Kosovo in 2007 to that in 2010?
Your answer should be compact. 3.26. What is the ratio of the Amount (in current US$) in Tanzania in 2007 to that in 2010?
Make the answer very short. 0.56. What is the ratio of the Amount (in current US$) of Sub-Saharan Africa (developing only) in 2007 to that in 2011?
Your answer should be very brief. 0.67. What is the ratio of the Amount (in current US$) of Belarus in 2007 to that in 2011?
Provide a succinct answer. 0.94. What is the ratio of the Amount (in current US$) of Kosovo in 2007 to that in 2011?
Offer a very short reply. 4.17. What is the ratio of the Amount (in current US$) of Tanzania in 2007 to that in 2011?
Your answer should be compact. 0.57. What is the ratio of the Amount (in current US$) of Sub-Saharan Africa (developing only) in 2007 to that in 2012?
Keep it short and to the point. 0.82. What is the ratio of the Amount (in current US$) of Belarus in 2007 to that in 2012?
Give a very brief answer. 22.1. What is the ratio of the Amount (in current US$) in Kosovo in 2007 to that in 2012?
Ensure brevity in your answer.  20.04. What is the ratio of the Amount (in current US$) of Tanzania in 2007 to that in 2012?
Keep it short and to the point. 0.7. What is the ratio of the Amount (in current US$) in Sub-Saharan Africa (developing only) in 2007 to that in 2013?
Ensure brevity in your answer.  0.57. What is the ratio of the Amount (in current US$) in Belarus in 2007 to that in 2013?
Your answer should be compact. 1.05. What is the ratio of the Amount (in current US$) of Kosovo in 2007 to that in 2013?
Provide a short and direct response. 6.97. What is the ratio of the Amount (in current US$) of Tanzania in 2007 to that in 2013?
Give a very brief answer. 0.33. What is the ratio of the Amount (in current US$) in Sub-Saharan Africa (developing only) in 2008 to that in 2009?
Your answer should be compact. 0.27. What is the ratio of the Amount (in current US$) of Belarus in 2008 to that in 2009?
Provide a succinct answer. 3.46. What is the ratio of the Amount (in current US$) of Tanzania in 2008 to that in 2009?
Keep it short and to the point. 0.52. What is the ratio of the Amount (in current US$) in Sub-Saharan Africa (developing only) in 2008 to that in 2010?
Your answer should be compact. 0.19. What is the ratio of the Amount (in current US$) in Belarus in 2008 to that in 2010?
Provide a succinct answer. 0.96. What is the ratio of the Amount (in current US$) in Kosovo in 2008 to that in 2010?
Keep it short and to the point. 1.32. What is the ratio of the Amount (in current US$) of Tanzania in 2008 to that in 2010?
Your answer should be very brief. 0.45. What is the ratio of the Amount (in current US$) in Sub-Saharan Africa (developing only) in 2008 to that in 2011?
Provide a short and direct response. 0.12. What is the ratio of the Amount (in current US$) of Belarus in 2008 to that in 2011?
Keep it short and to the point. 0.8. What is the ratio of the Amount (in current US$) of Kosovo in 2008 to that in 2011?
Offer a terse response. 1.68. What is the ratio of the Amount (in current US$) in Tanzania in 2008 to that in 2011?
Ensure brevity in your answer.  0.45. What is the ratio of the Amount (in current US$) of Sub-Saharan Africa (developing only) in 2008 to that in 2012?
Provide a short and direct response. 0.15. What is the ratio of the Amount (in current US$) of Belarus in 2008 to that in 2012?
Provide a succinct answer. 18.87. What is the ratio of the Amount (in current US$) of Kosovo in 2008 to that in 2012?
Keep it short and to the point. 8.09. What is the ratio of the Amount (in current US$) of Tanzania in 2008 to that in 2012?
Offer a very short reply. 0.56. What is the ratio of the Amount (in current US$) in Sub-Saharan Africa (developing only) in 2008 to that in 2013?
Give a very brief answer. 0.1. What is the ratio of the Amount (in current US$) in Belarus in 2008 to that in 2013?
Keep it short and to the point. 0.9. What is the ratio of the Amount (in current US$) in Kosovo in 2008 to that in 2013?
Ensure brevity in your answer.  2.82. What is the ratio of the Amount (in current US$) of Tanzania in 2008 to that in 2013?
Offer a very short reply. 0.26. What is the ratio of the Amount (in current US$) of Sub-Saharan Africa (developing only) in 2009 to that in 2010?
Your answer should be compact. 0.7. What is the ratio of the Amount (in current US$) in Belarus in 2009 to that in 2010?
Ensure brevity in your answer.  0.28. What is the ratio of the Amount (in current US$) of Tanzania in 2009 to that in 2010?
Your answer should be compact. 0.85. What is the ratio of the Amount (in current US$) in Sub-Saharan Africa (developing only) in 2009 to that in 2011?
Your response must be concise. 0.45. What is the ratio of the Amount (in current US$) of Belarus in 2009 to that in 2011?
Your answer should be very brief. 0.23. What is the ratio of the Amount (in current US$) in Tanzania in 2009 to that in 2011?
Your answer should be very brief. 0.87. What is the ratio of the Amount (in current US$) in Sub-Saharan Africa (developing only) in 2009 to that in 2012?
Your response must be concise. 0.55. What is the ratio of the Amount (in current US$) in Belarus in 2009 to that in 2012?
Ensure brevity in your answer.  5.45. What is the ratio of the Amount (in current US$) in Tanzania in 2009 to that in 2012?
Ensure brevity in your answer.  1.07. What is the ratio of the Amount (in current US$) of Sub-Saharan Africa (developing only) in 2009 to that in 2013?
Make the answer very short. 0.38. What is the ratio of the Amount (in current US$) in Belarus in 2009 to that in 2013?
Ensure brevity in your answer.  0.26. What is the ratio of the Amount (in current US$) in Tanzania in 2009 to that in 2013?
Give a very brief answer. 0.5. What is the ratio of the Amount (in current US$) in Sub-Saharan Africa (developing only) in 2010 to that in 2011?
Offer a terse response. 0.64. What is the ratio of the Amount (in current US$) of Belarus in 2010 to that in 2011?
Your answer should be compact. 0.83. What is the ratio of the Amount (in current US$) of Kosovo in 2010 to that in 2011?
Ensure brevity in your answer.  1.28. What is the ratio of the Amount (in current US$) of Tanzania in 2010 to that in 2011?
Your answer should be very brief. 1.02. What is the ratio of the Amount (in current US$) of Sub-Saharan Africa (developing only) in 2010 to that in 2012?
Ensure brevity in your answer.  0.78. What is the ratio of the Amount (in current US$) of Belarus in 2010 to that in 2012?
Ensure brevity in your answer.  19.61. What is the ratio of the Amount (in current US$) in Kosovo in 2010 to that in 2012?
Offer a terse response. 6.14. What is the ratio of the Amount (in current US$) in Tanzania in 2010 to that in 2012?
Your answer should be very brief. 1.25. What is the ratio of the Amount (in current US$) in Sub-Saharan Africa (developing only) in 2010 to that in 2013?
Your response must be concise. 0.54. What is the ratio of the Amount (in current US$) in Belarus in 2010 to that in 2013?
Provide a succinct answer. 0.93. What is the ratio of the Amount (in current US$) of Kosovo in 2010 to that in 2013?
Provide a short and direct response. 2.14. What is the ratio of the Amount (in current US$) of Tanzania in 2010 to that in 2013?
Ensure brevity in your answer.  0.58. What is the ratio of the Amount (in current US$) in Sub-Saharan Africa (developing only) in 2011 to that in 2012?
Keep it short and to the point. 1.23. What is the ratio of the Amount (in current US$) in Belarus in 2011 to that in 2012?
Provide a short and direct response. 23.56. What is the ratio of the Amount (in current US$) of Kosovo in 2011 to that in 2012?
Offer a terse response. 4.8. What is the ratio of the Amount (in current US$) in Tanzania in 2011 to that in 2012?
Provide a succinct answer. 1.23. What is the ratio of the Amount (in current US$) in Sub-Saharan Africa (developing only) in 2011 to that in 2013?
Offer a very short reply. 0.85. What is the ratio of the Amount (in current US$) of Belarus in 2011 to that in 2013?
Your answer should be very brief. 1.12. What is the ratio of the Amount (in current US$) of Kosovo in 2011 to that in 2013?
Make the answer very short. 1.67. What is the ratio of the Amount (in current US$) in Tanzania in 2011 to that in 2013?
Offer a very short reply. 0.57. What is the ratio of the Amount (in current US$) of Sub-Saharan Africa (developing only) in 2012 to that in 2013?
Keep it short and to the point. 0.69. What is the ratio of the Amount (in current US$) of Belarus in 2012 to that in 2013?
Your response must be concise. 0.05. What is the ratio of the Amount (in current US$) of Kosovo in 2012 to that in 2013?
Your response must be concise. 0.35. What is the ratio of the Amount (in current US$) of Tanzania in 2012 to that in 2013?
Make the answer very short. 0.47. What is the difference between the highest and the second highest Amount (in current US$) of Sub-Saharan Africa (developing only)?
Your response must be concise. 4.33e+09. What is the difference between the highest and the second highest Amount (in current US$) of Belarus?
Your answer should be very brief. 1.90e+08. What is the difference between the highest and the second highest Amount (in current US$) in Kosovo?
Give a very brief answer. 1.83e+08. What is the difference between the highest and the second highest Amount (in current US$) in Tanzania?
Ensure brevity in your answer.  8.04e+08. What is the difference between the highest and the lowest Amount (in current US$) in Sub-Saharan Africa (developing only)?
Your response must be concise. 2.59e+1. What is the difference between the highest and the lowest Amount (in current US$) in Belarus?
Your response must be concise. 2.94e+09. What is the difference between the highest and the lowest Amount (in current US$) of Kosovo?
Provide a short and direct response. 3.07e+08. What is the difference between the highest and the lowest Amount (in current US$) in Tanzania?
Provide a succinct answer. 1.43e+09. 